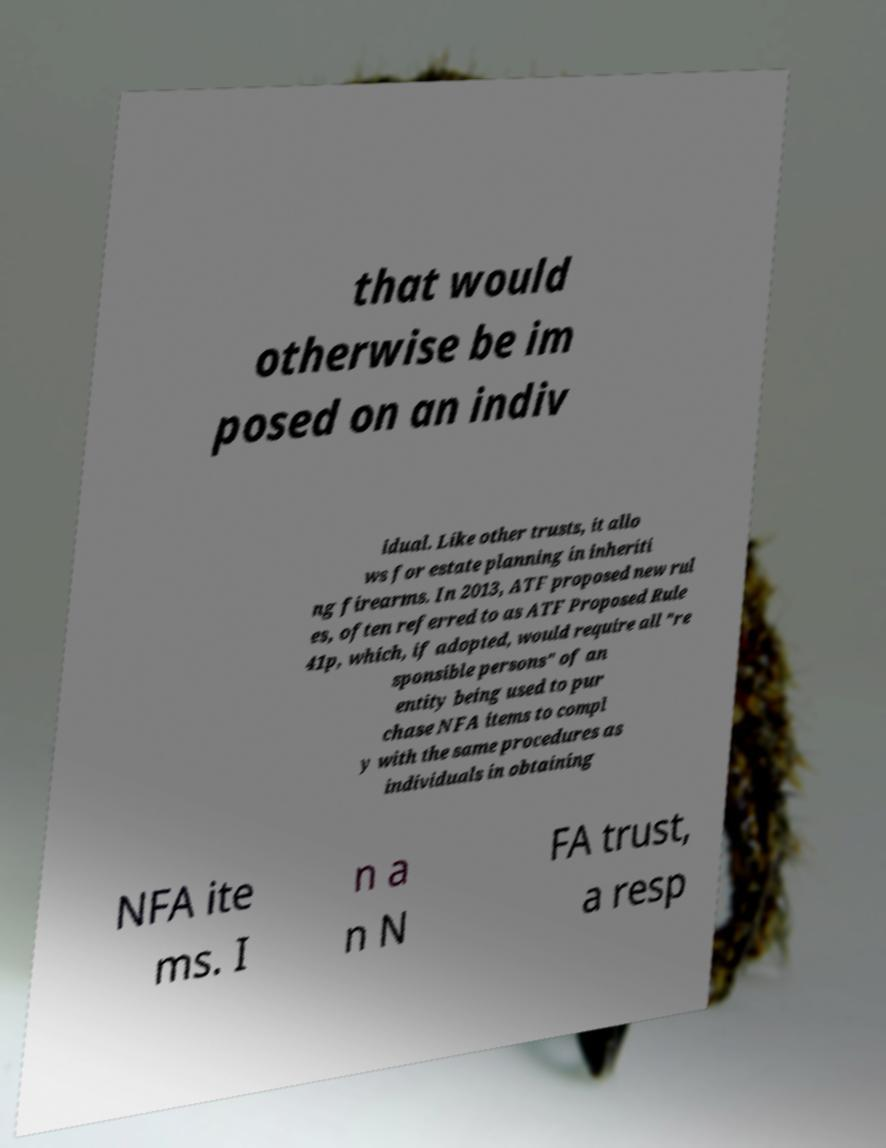Can you accurately transcribe the text from the provided image for me? that would otherwise be im posed on an indiv idual. Like other trusts, it allo ws for estate planning in inheriti ng firearms. In 2013, ATF proposed new rul es, often referred to as ATF Proposed Rule 41p, which, if adopted, would require all "re sponsible persons" of an entity being used to pur chase NFA items to compl y with the same procedures as individuals in obtaining NFA ite ms. I n a n N FA trust, a resp 